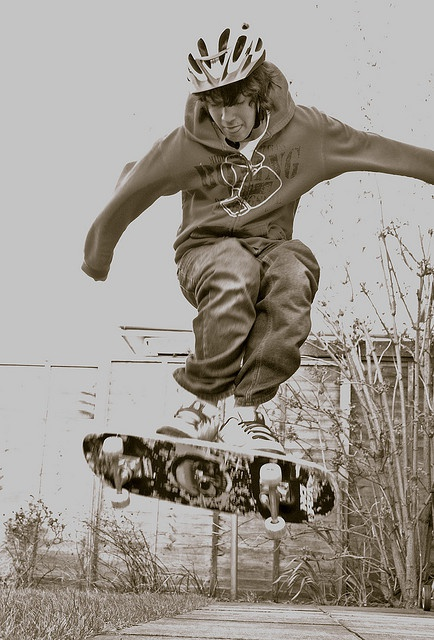Describe the objects in this image and their specific colors. I can see people in lightgray, gray, and black tones and skateboard in lightgray, black, darkgray, and gray tones in this image. 